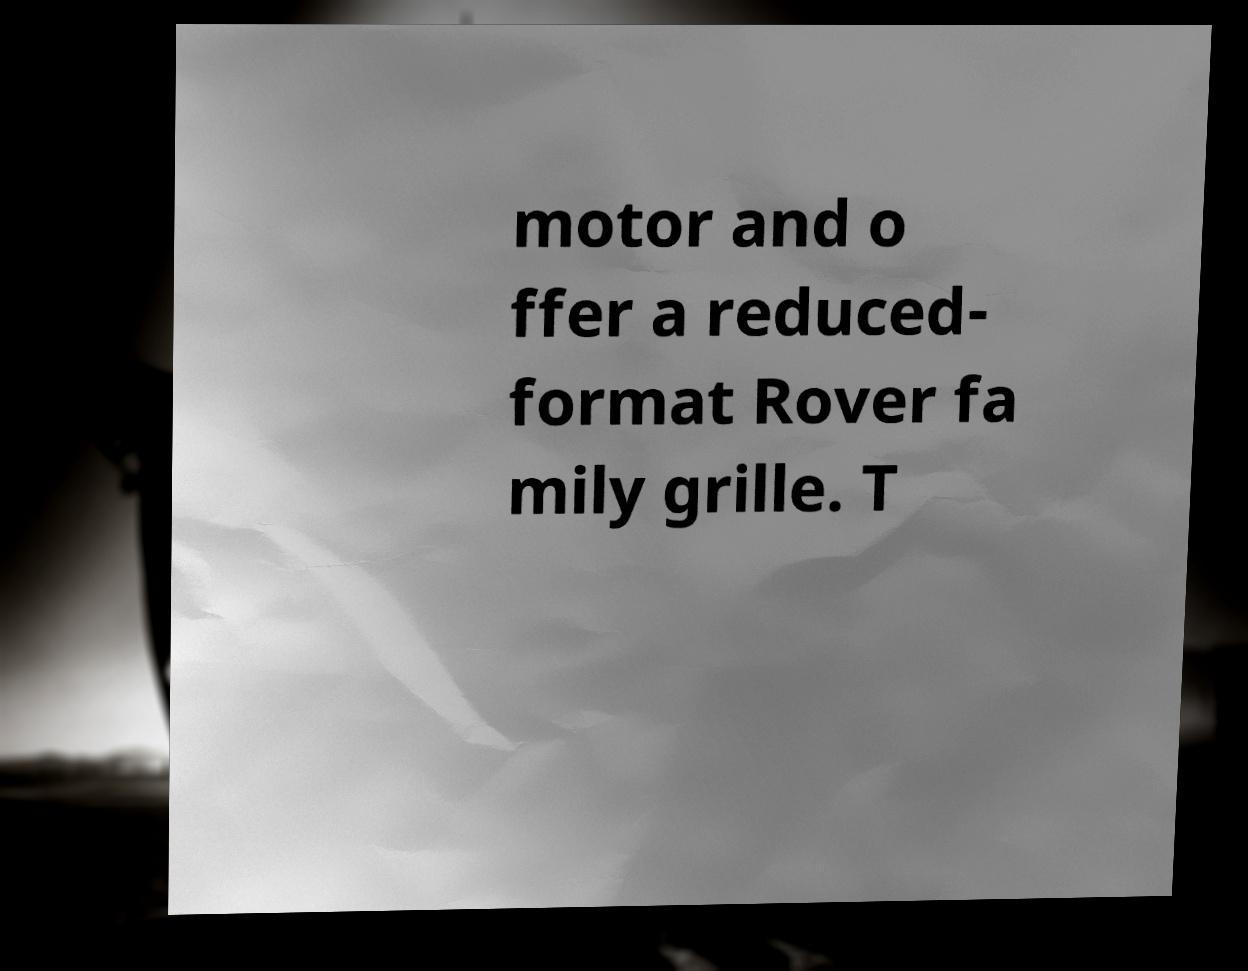For documentation purposes, I need the text within this image transcribed. Could you provide that? motor and o ffer a reduced- format Rover fa mily grille. T 